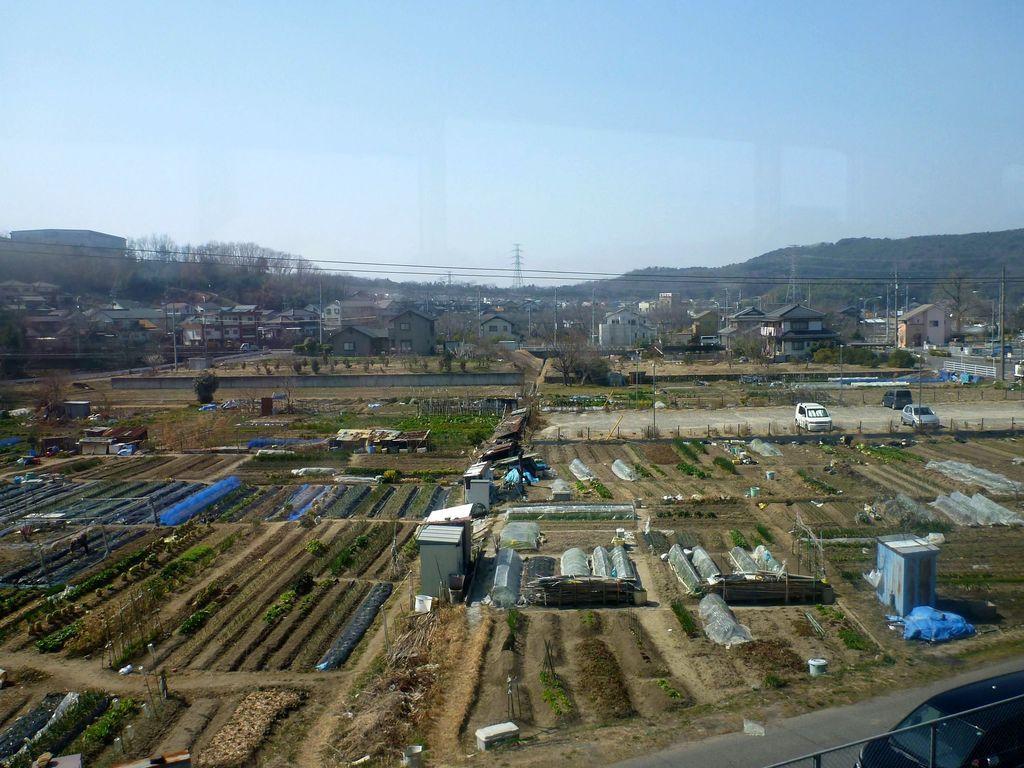Please provide a concise description of this image. In the background of the image there are buildings,trees,poles,mountains. In the center of the image there are crops. To the right side of the image there are vehicles. At the bottom of the image there is road. There is fencing. At the top of the image there is sky. 